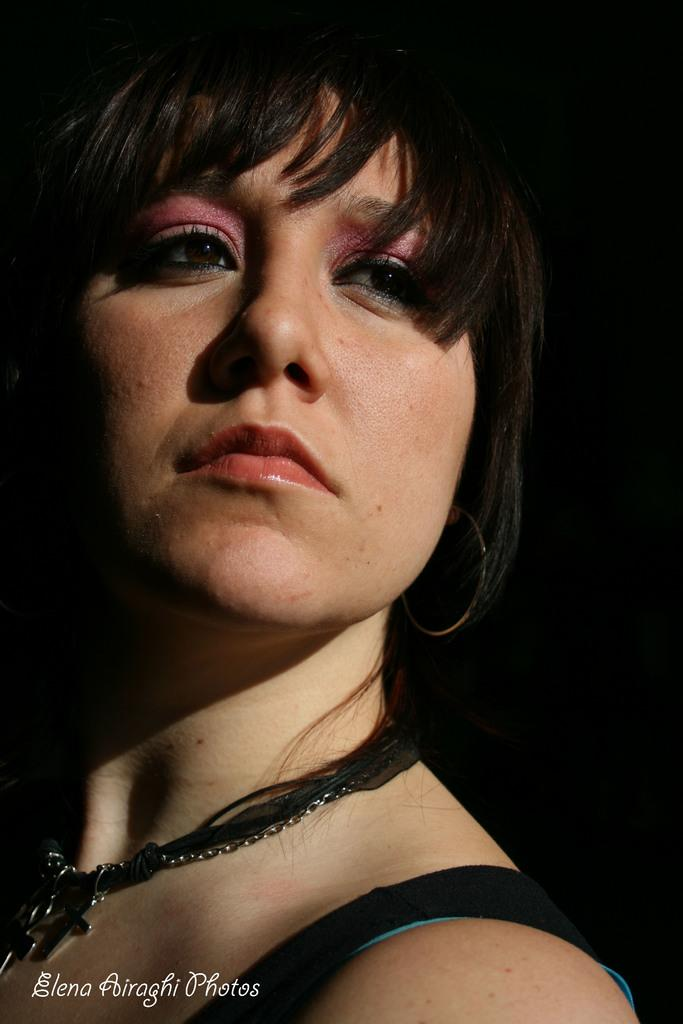Who is present in the image? There is a woman in the image. What else can be seen at the bottom of the image? There is text at the bottom side of the image. What type of oatmeal is the woman eating in the image? There is no oatmeal present in the image, and the woman's actions are not described. 